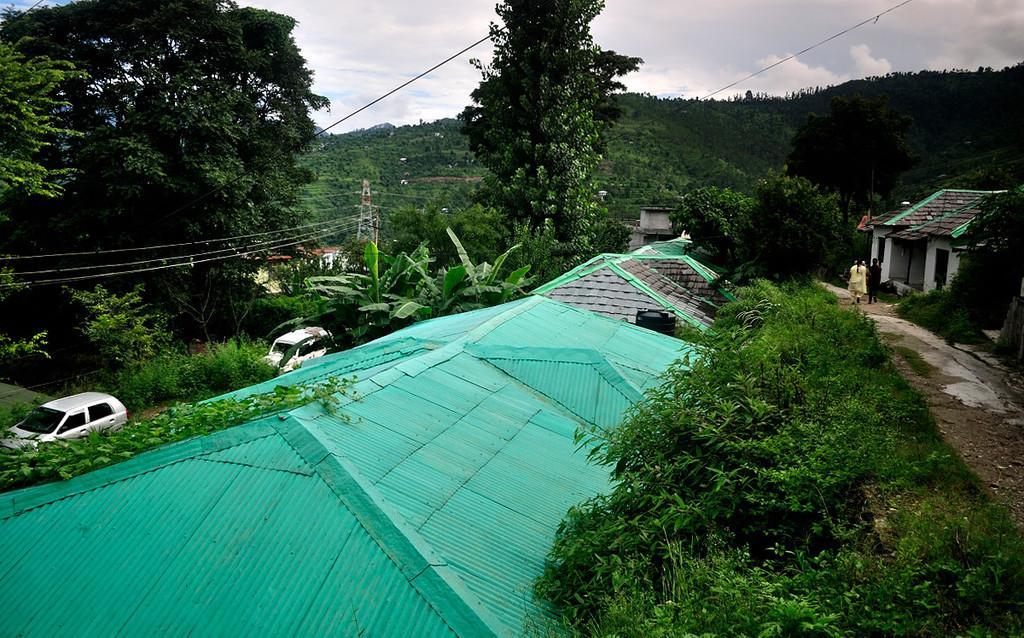Please provide a concise description of this image. In this image in the front there are trees. In the center there are houses. On the right side there are houses and there are persons walking. In the background there are vehicles, trees, poles and wires and the sky is cloudy. 